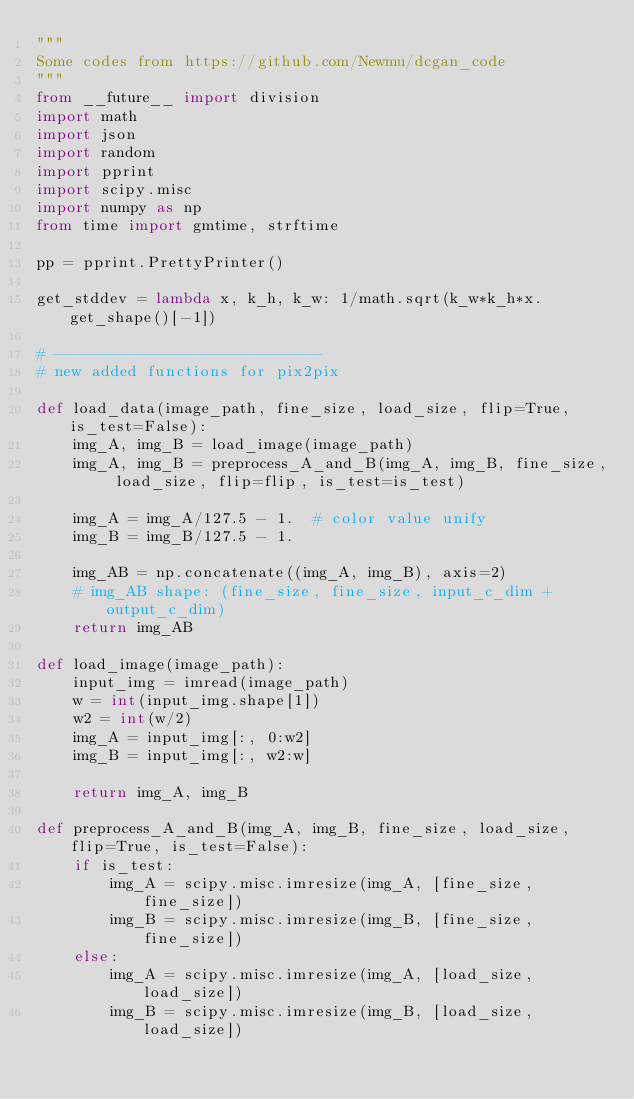<code> <loc_0><loc_0><loc_500><loc_500><_Python_>"""
Some codes from https://github.com/Newmu/dcgan_code
"""
from __future__ import division
import math
import json
import random
import pprint
import scipy.misc
import numpy as np
from time import gmtime, strftime

pp = pprint.PrettyPrinter()

get_stddev = lambda x, k_h, k_w: 1/math.sqrt(k_w*k_h*x.get_shape()[-1])

# -----------------------------
# new added functions for pix2pix

def load_data(image_path, fine_size, load_size, flip=True, is_test=False):
    img_A, img_B = load_image(image_path)
    img_A, img_B = preprocess_A_and_B(img_A, img_B, fine_size, load_size, flip=flip, is_test=is_test)

    img_A = img_A/127.5 - 1.  # color value unify
    img_B = img_B/127.5 - 1.

    img_AB = np.concatenate((img_A, img_B), axis=2)
    # img_AB shape: (fine_size, fine_size, input_c_dim + output_c_dim)
    return img_AB

def load_image(image_path):
    input_img = imread(image_path)
    w = int(input_img.shape[1])
    w2 = int(w/2)
    img_A = input_img[:, 0:w2]
    img_B = input_img[:, w2:w]

    return img_A, img_B

def preprocess_A_and_B(img_A, img_B, fine_size, load_size, flip=True, is_test=False):
    if is_test:
        img_A = scipy.misc.imresize(img_A, [fine_size, fine_size])
        img_B = scipy.misc.imresize(img_B, [fine_size, fine_size])
    else:
        img_A = scipy.misc.imresize(img_A, [load_size, load_size])
        img_B = scipy.misc.imresize(img_B, [load_size, load_size])
</code> 